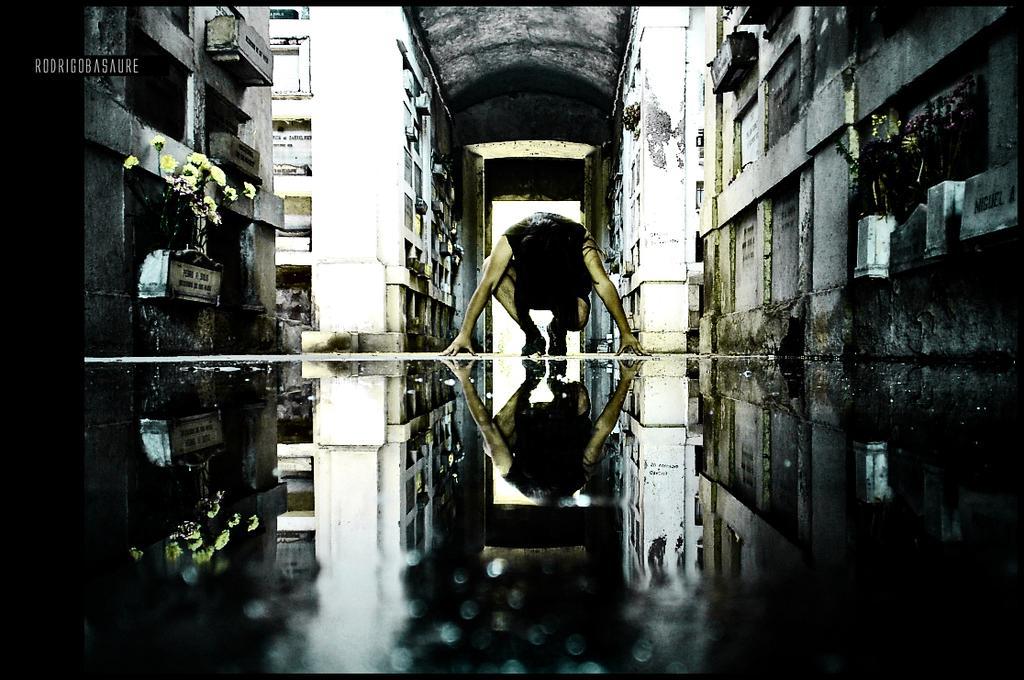How would you summarize this image in a sentence or two? In the image we can see there is a person sitting on the ground and there is water on the ground. The reflection of person is seen in the water and behind there is a building. There are flowers grown on the wall in small blocks attached to the wall. 